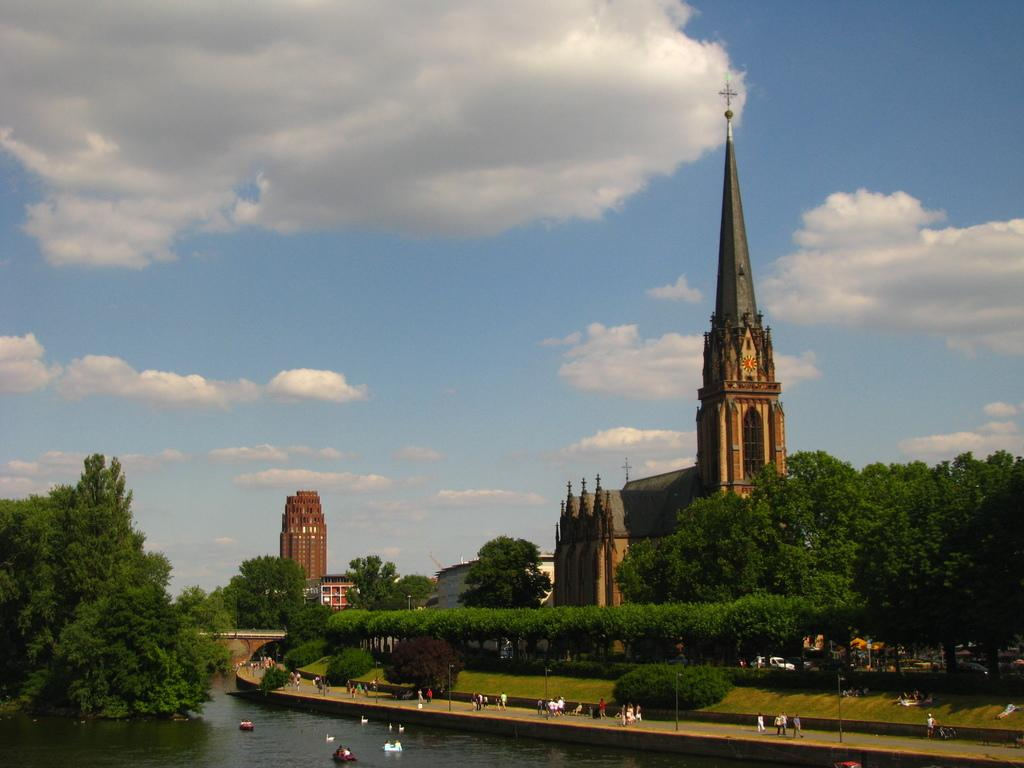What is the main feature of the image? The main feature of the image is water. What are the people in the image doing? The people in the image are walking on a bridge. What can be seen in the background of the image? There are buildings and trees with green color in the background of the image. How would you describe the sky in the image? The sky in the image is blue and white in color. How much payment is required to cross the boundary in the image? There is no payment or boundary mentioned in the image; it simply shows people walking on a bridge over water. 